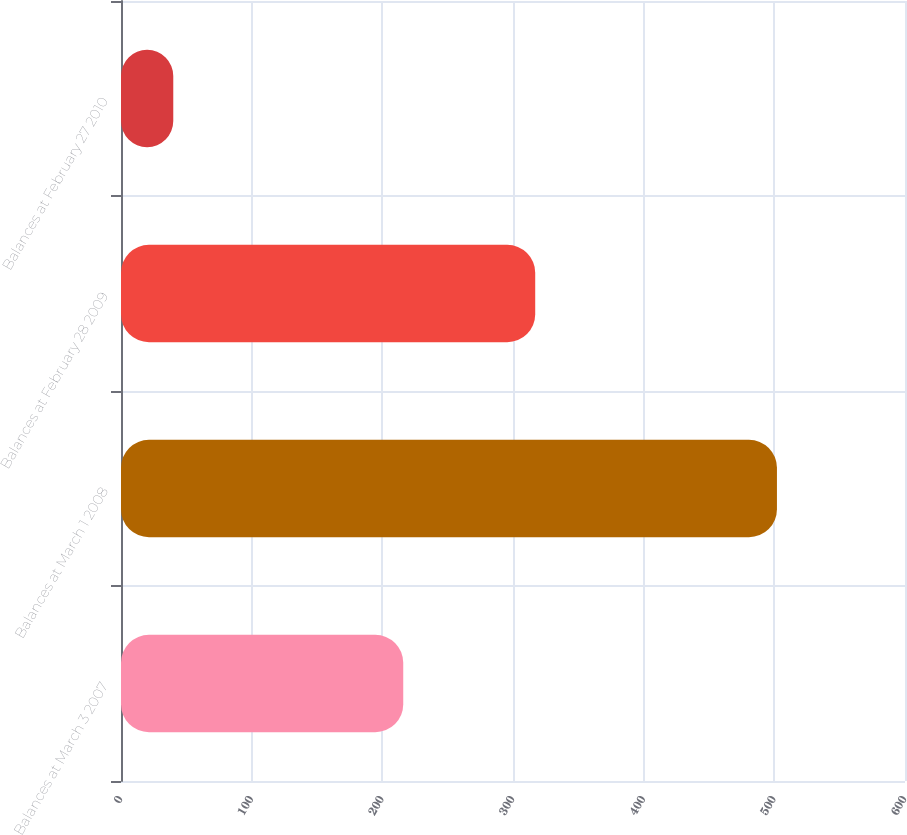Convert chart to OTSL. <chart><loc_0><loc_0><loc_500><loc_500><bar_chart><fcel>Balances at March 3 2007<fcel>Balances at March 1 2008<fcel>Balances at February 28 2009<fcel>Balances at February 27 2010<nl><fcel>216<fcel>502<fcel>317<fcel>40<nl></chart> 